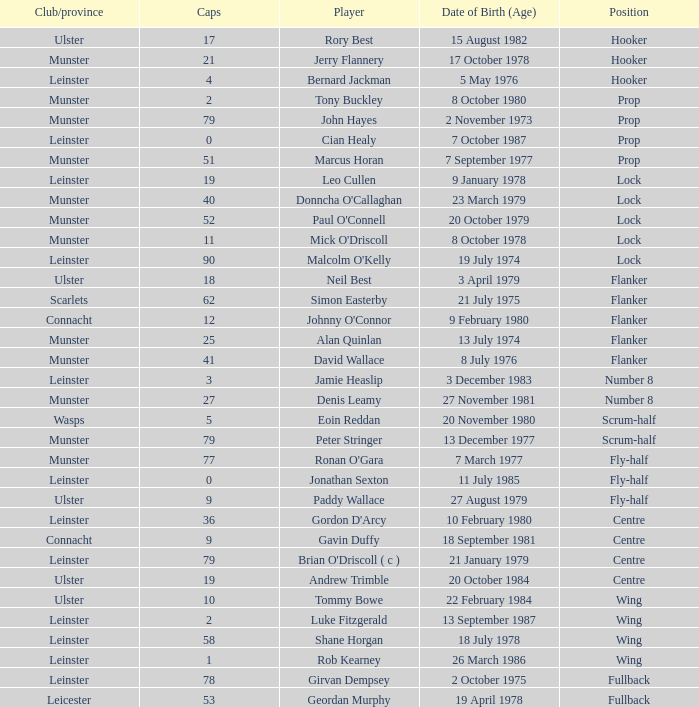How many Caps does the Club/province Munster, position of lock and Mick O'Driscoll have? 1.0. 